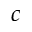<formula> <loc_0><loc_0><loc_500><loc_500>c</formula> 